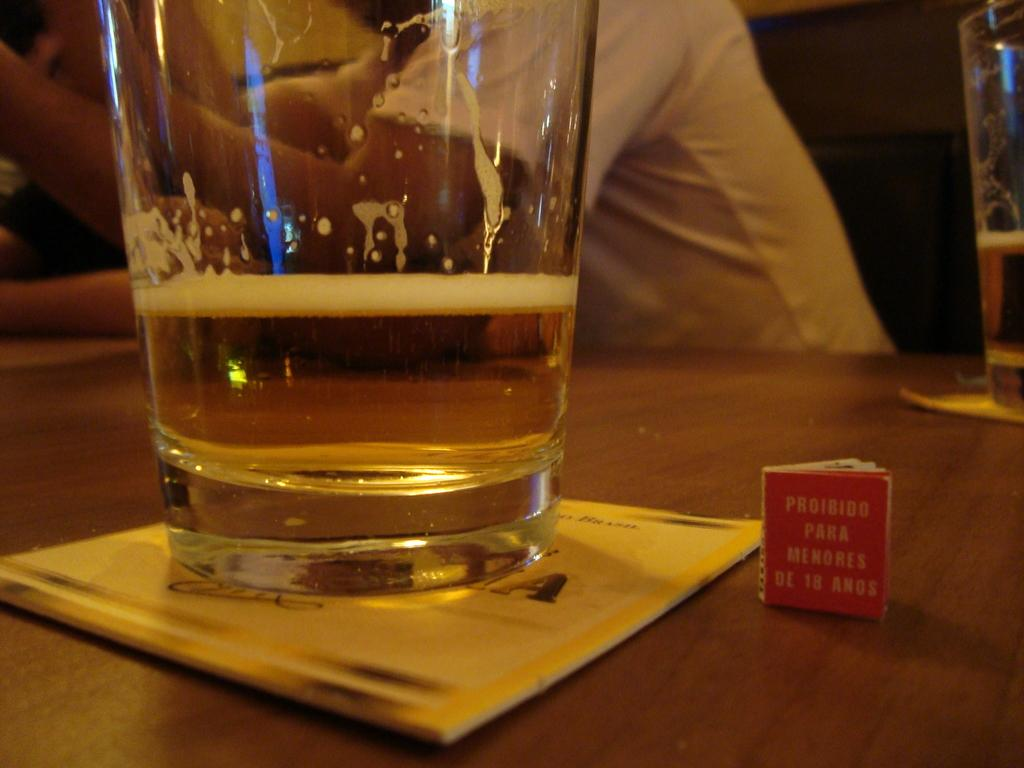<image>
Create a compact narrative representing the image presented. A tiny book that says Proibido Para Menores De 18 Anos sits next to a glass of beer. 